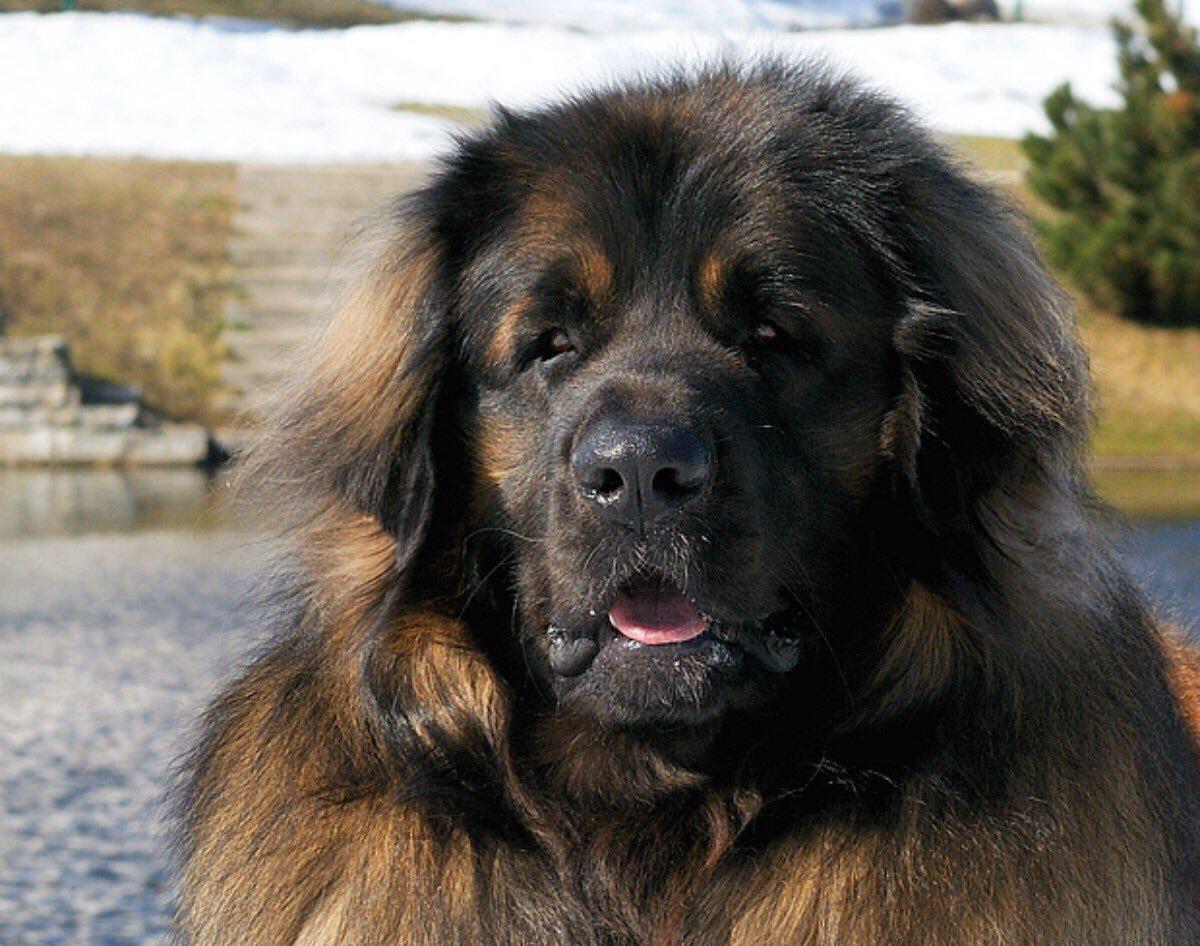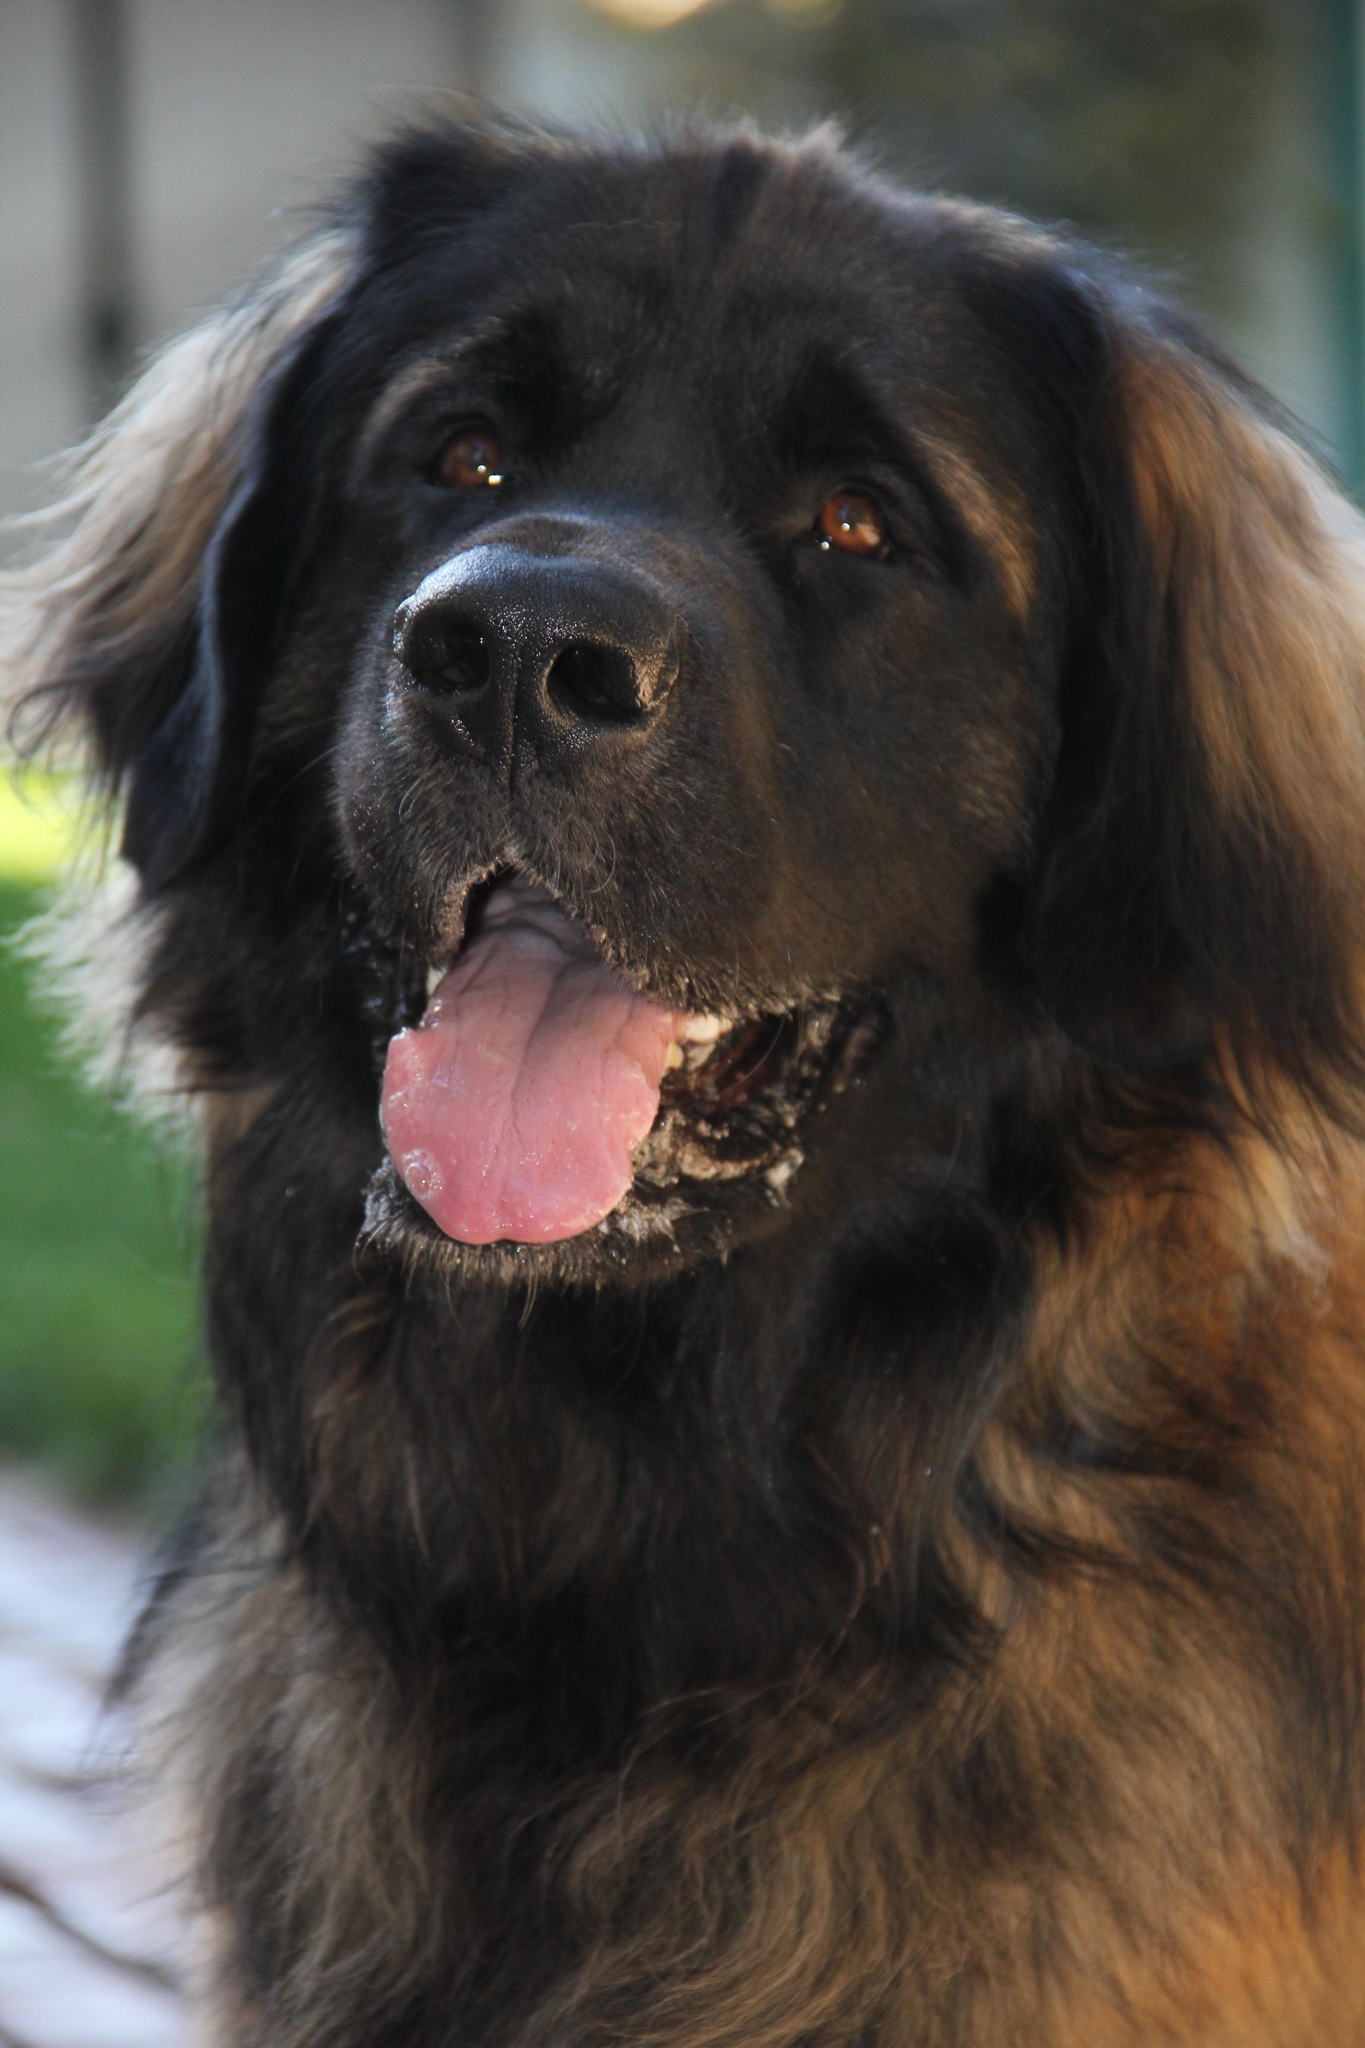The first image is the image on the left, the second image is the image on the right. Examine the images to the left and right. Is the description "There are a total of exactly two dogs." accurate? Answer yes or no. Yes. The first image is the image on the left, the second image is the image on the right. Examine the images to the left and right. Is the description "There are at most two dogs." accurate? Answer yes or no. Yes. 